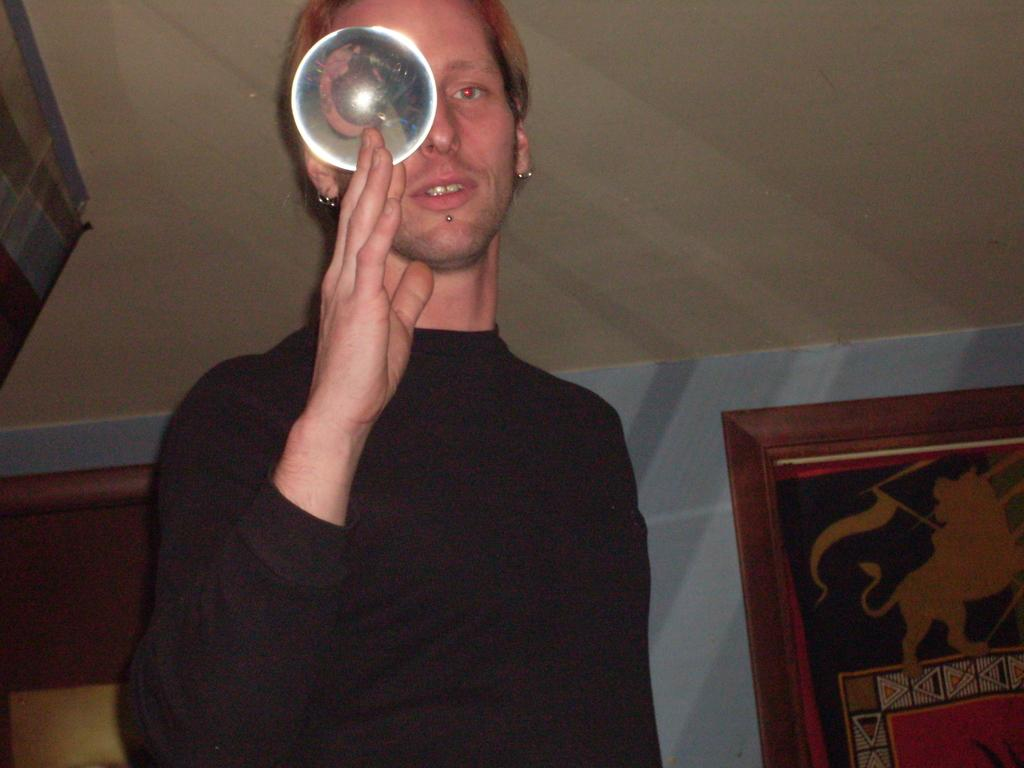What is the man in the image doing? The man is standing in the image. What is the man holding in his hand? The man is holding a disc in his hand. What can be seen in the background of the image? There are wall hangings in the background of the image. What type of oven can be seen in the image? There is no oven present in the image. What is the aftermath of the man's action in the image? The image does not depict any action being taken by the man, so there is no aftermath to describe. 